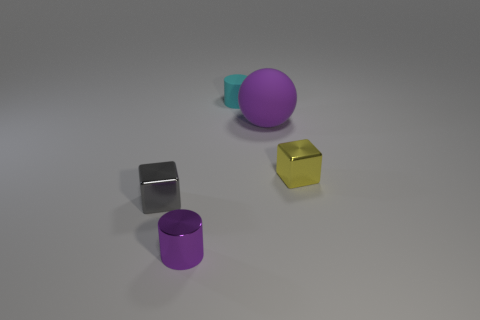What textures are visible on the objects? The objects appear to have relatively smooth textures. The yellow and gray cubes have a metallic sheen, the purple sphere looks like it has a matte finish, and the cyan and purple cylinders seem to have a slightly reflective surface as well. 